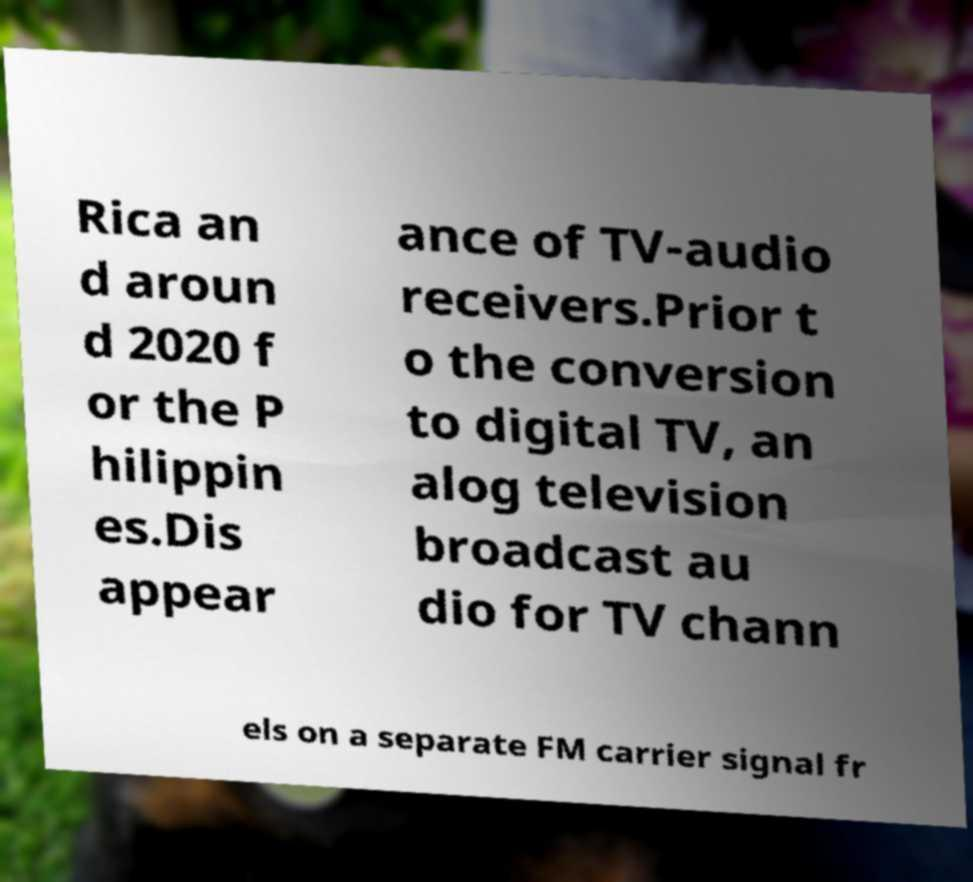Could you extract and type out the text from this image? Rica an d aroun d 2020 f or the P hilippin es.Dis appear ance of TV-audio receivers.Prior t o the conversion to digital TV, an alog television broadcast au dio for TV chann els on a separate FM carrier signal fr 